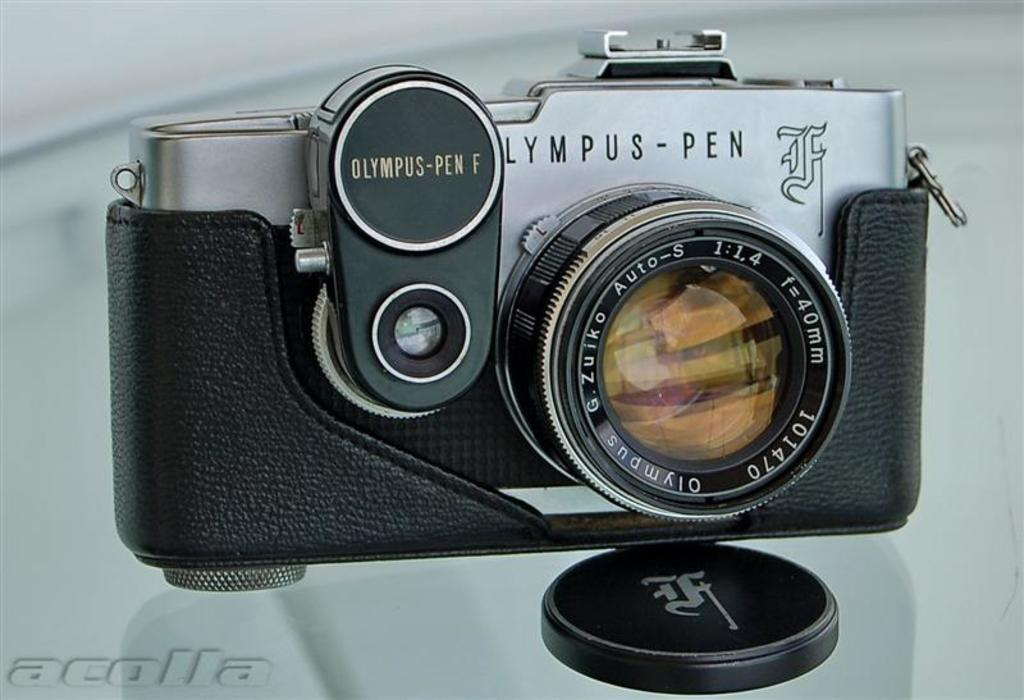What is the main subject of the image? The main subject of the image is a camera. What can be seen attached to the camera? There are camera lenses in the image. Is there any text on the camera? Yes, there is text on the camera. Can you describe any additional elements in the image? There is a watermark in the bottom left corner of the image. What type of music can be heard playing in the background of the image? There is no music playing in the background of the image; it is a still photograph of a camera. 